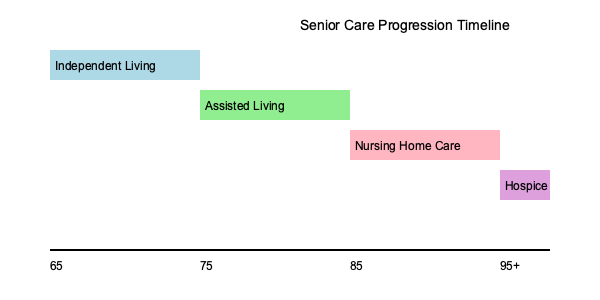Based on the timeline graphic, at approximately what age does the typical progression of senior care needs indicate a transition from Assisted Living to Nursing Home Care? To answer this question, we need to analyze the timeline graphic showing the progression of care needs for seniors. Let's break it down step-by-step:

1. The timeline spans from age 65 to 95+ years.
2. There are four main care stages shown:
   a) Independent Living
   b) Assisted Living
   c) Nursing Home Care
   d) Hospice

3. Each care stage is represented by a colored rectangle positioned along the timeline.

4. To find the transition age from Assisted Living to Nursing Home Care, we need to locate where the Assisted Living rectangle ends and the Nursing Home Care rectangle begins.

5. The Assisted Living rectangle starts at the 75-year mark on the timeline.

6. The Nursing Home Care rectangle begins at the 85-year mark on the timeline.

7. This indicates that the transition from Assisted Living to Nursing Home Care typically occurs around age 85.

Therefore, according to this timeline graphic, the transition from Assisted Living to Nursing Home Care is shown to occur at approximately 85 years of age.
Answer: 85 years 